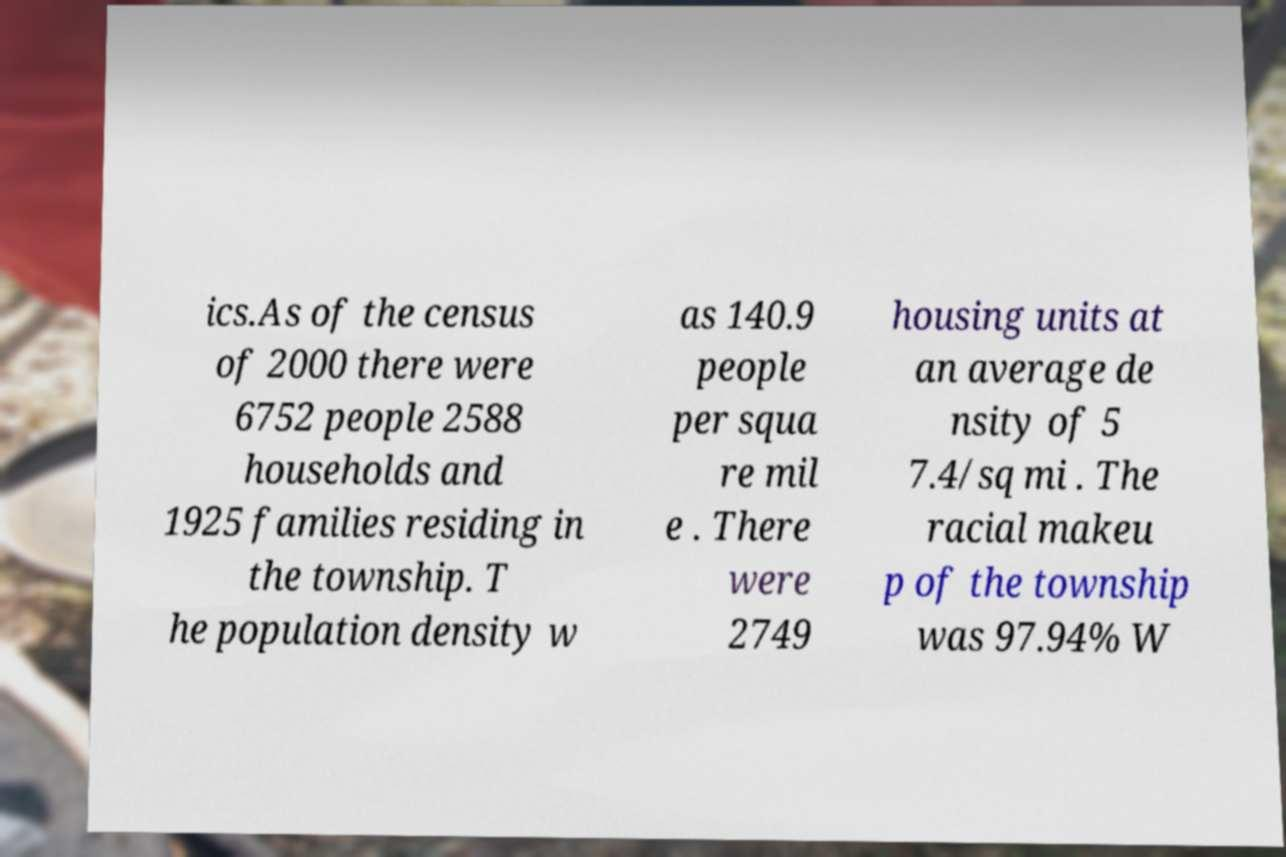Could you assist in decoding the text presented in this image and type it out clearly? ics.As of the census of 2000 there were 6752 people 2588 households and 1925 families residing in the township. T he population density w as 140.9 people per squa re mil e . There were 2749 housing units at an average de nsity of 5 7.4/sq mi . The racial makeu p of the township was 97.94% W 